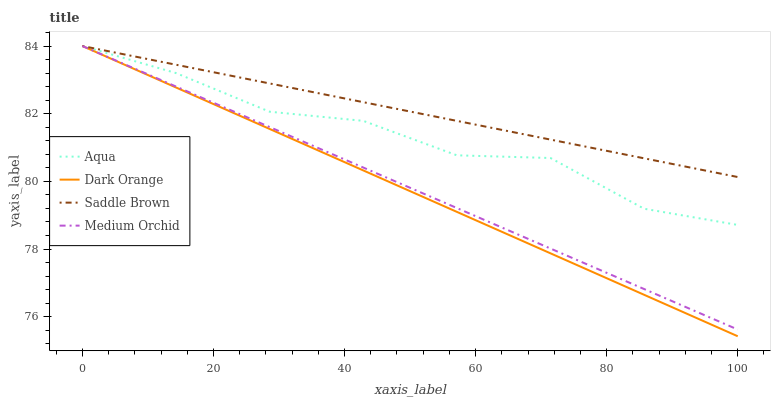Does Medium Orchid have the minimum area under the curve?
Answer yes or no. No. Does Medium Orchid have the maximum area under the curve?
Answer yes or no. No. Is Medium Orchid the smoothest?
Answer yes or no. No. Is Medium Orchid the roughest?
Answer yes or no. No. Does Medium Orchid have the lowest value?
Answer yes or no. No. 